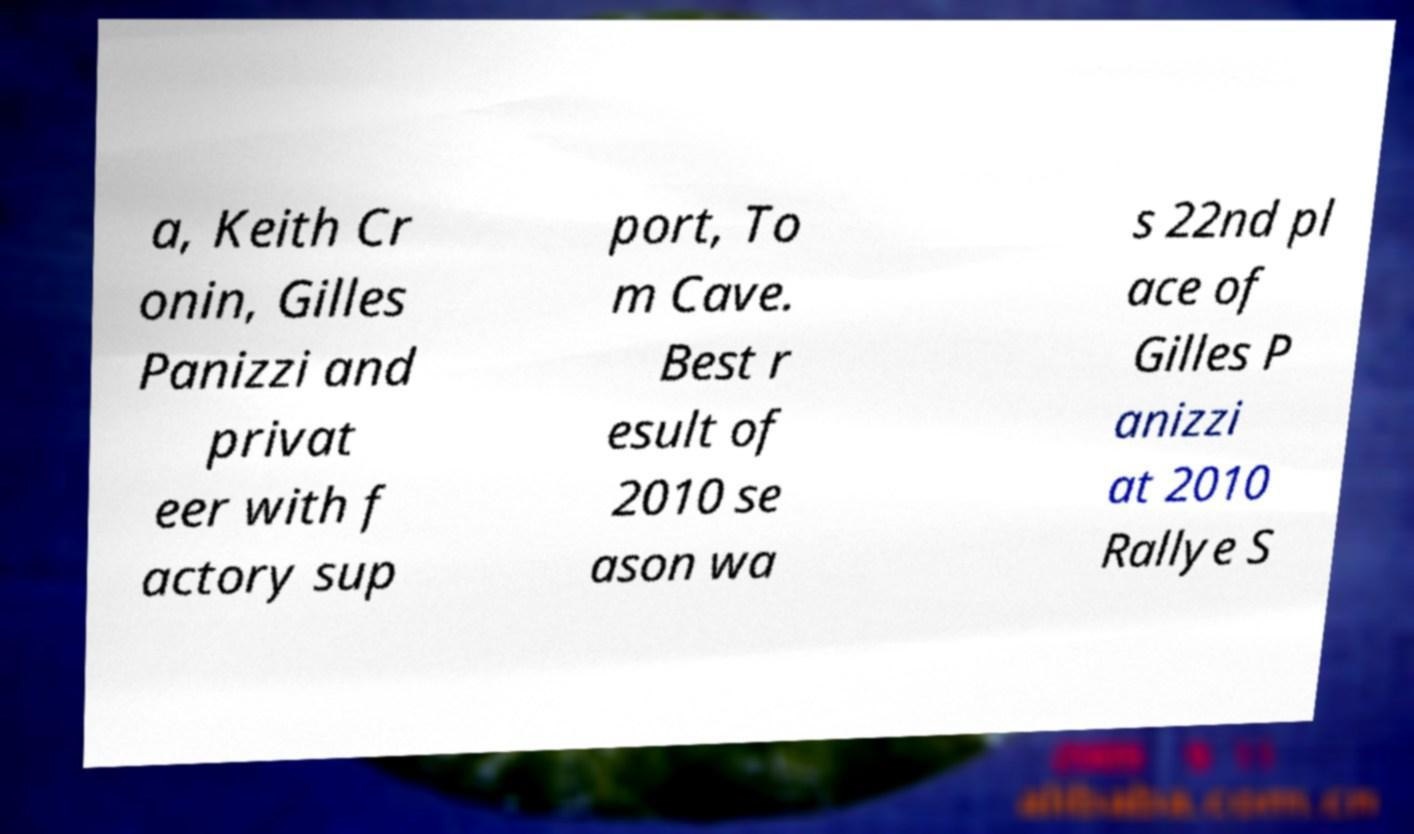Could you assist in decoding the text presented in this image and type it out clearly? a, Keith Cr onin, Gilles Panizzi and privat eer with f actory sup port, To m Cave. Best r esult of 2010 se ason wa s 22nd pl ace of Gilles P anizzi at 2010 Rallye S 